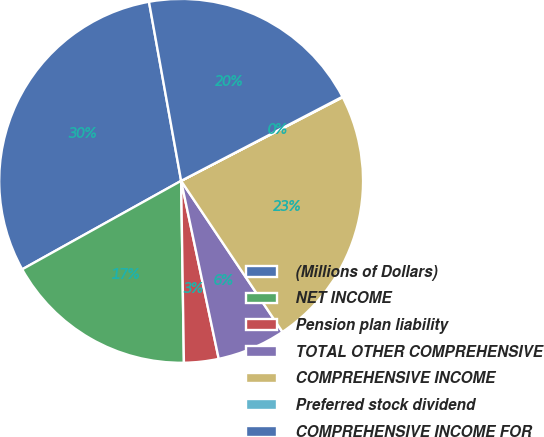Convert chart. <chart><loc_0><loc_0><loc_500><loc_500><pie_chart><fcel>(Millions of Dollars)<fcel>NET INCOME<fcel>Pension plan liability<fcel>TOTAL OTHER COMPREHENSIVE<fcel>COMPREHENSIVE INCOME<fcel>Preferred stock dividend<fcel>COMPREHENSIVE INCOME FOR<nl><fcel>30.26%<fcel>17.16%<fcel>3.07%<fcel>6.09%<fcel>23.2%<fcel>0.05%<fcel>20.18%<nl></chart> 